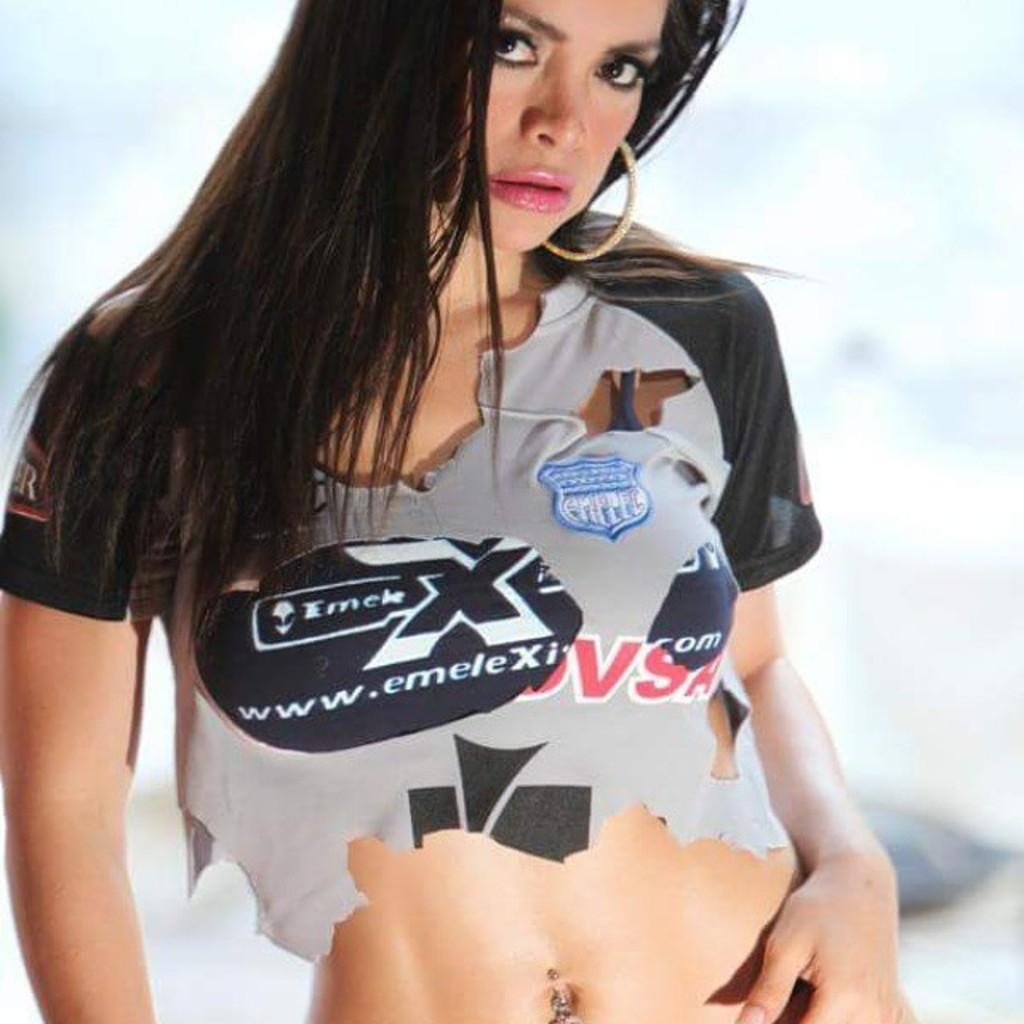Provide a one-sentence caption for the provided image. A girl with a tattered shirt advertising emeleX. 